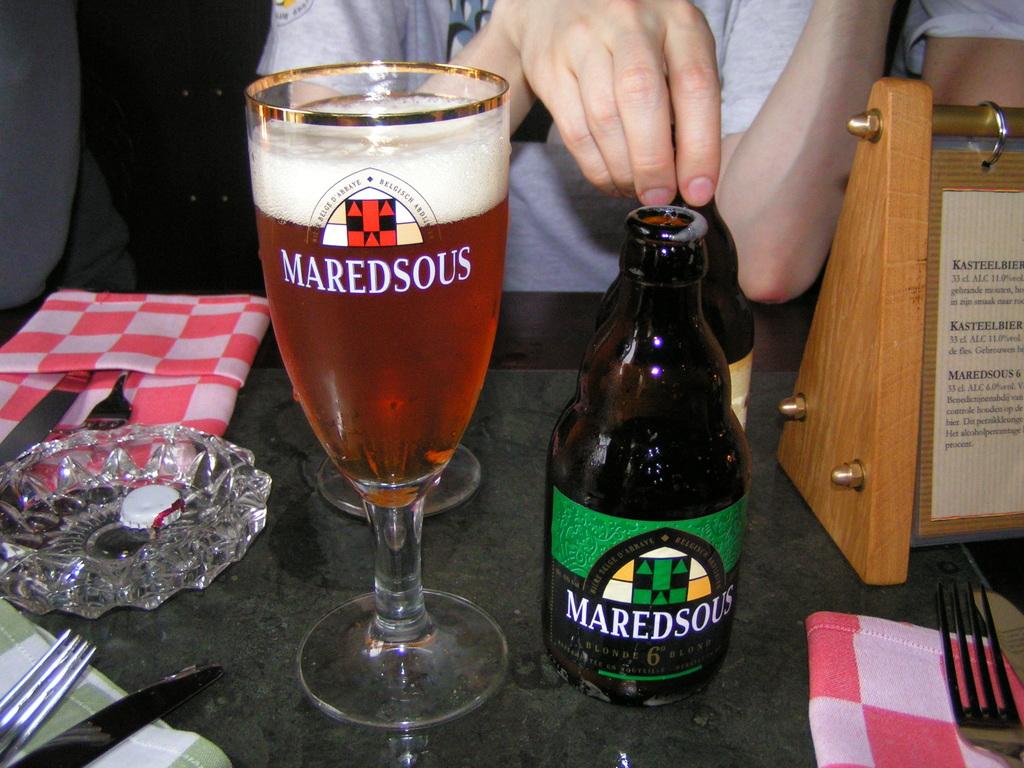What is the brand of alcohol?
Your response must be concise. Maredsous. What type of beer is this?
Offer a very short reply. Maredsous. 